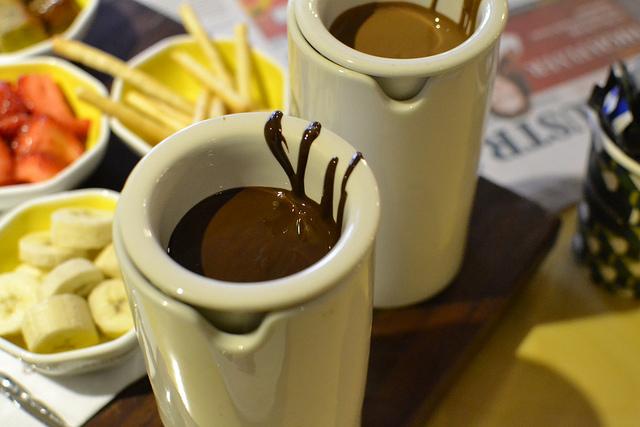Is there bananas in the photo?
Concise answer only. Yes. Is that chocolate or fudge?
Give a very brief answer. Chocolate. Is this a high class meal?
Answer briefly. No. 